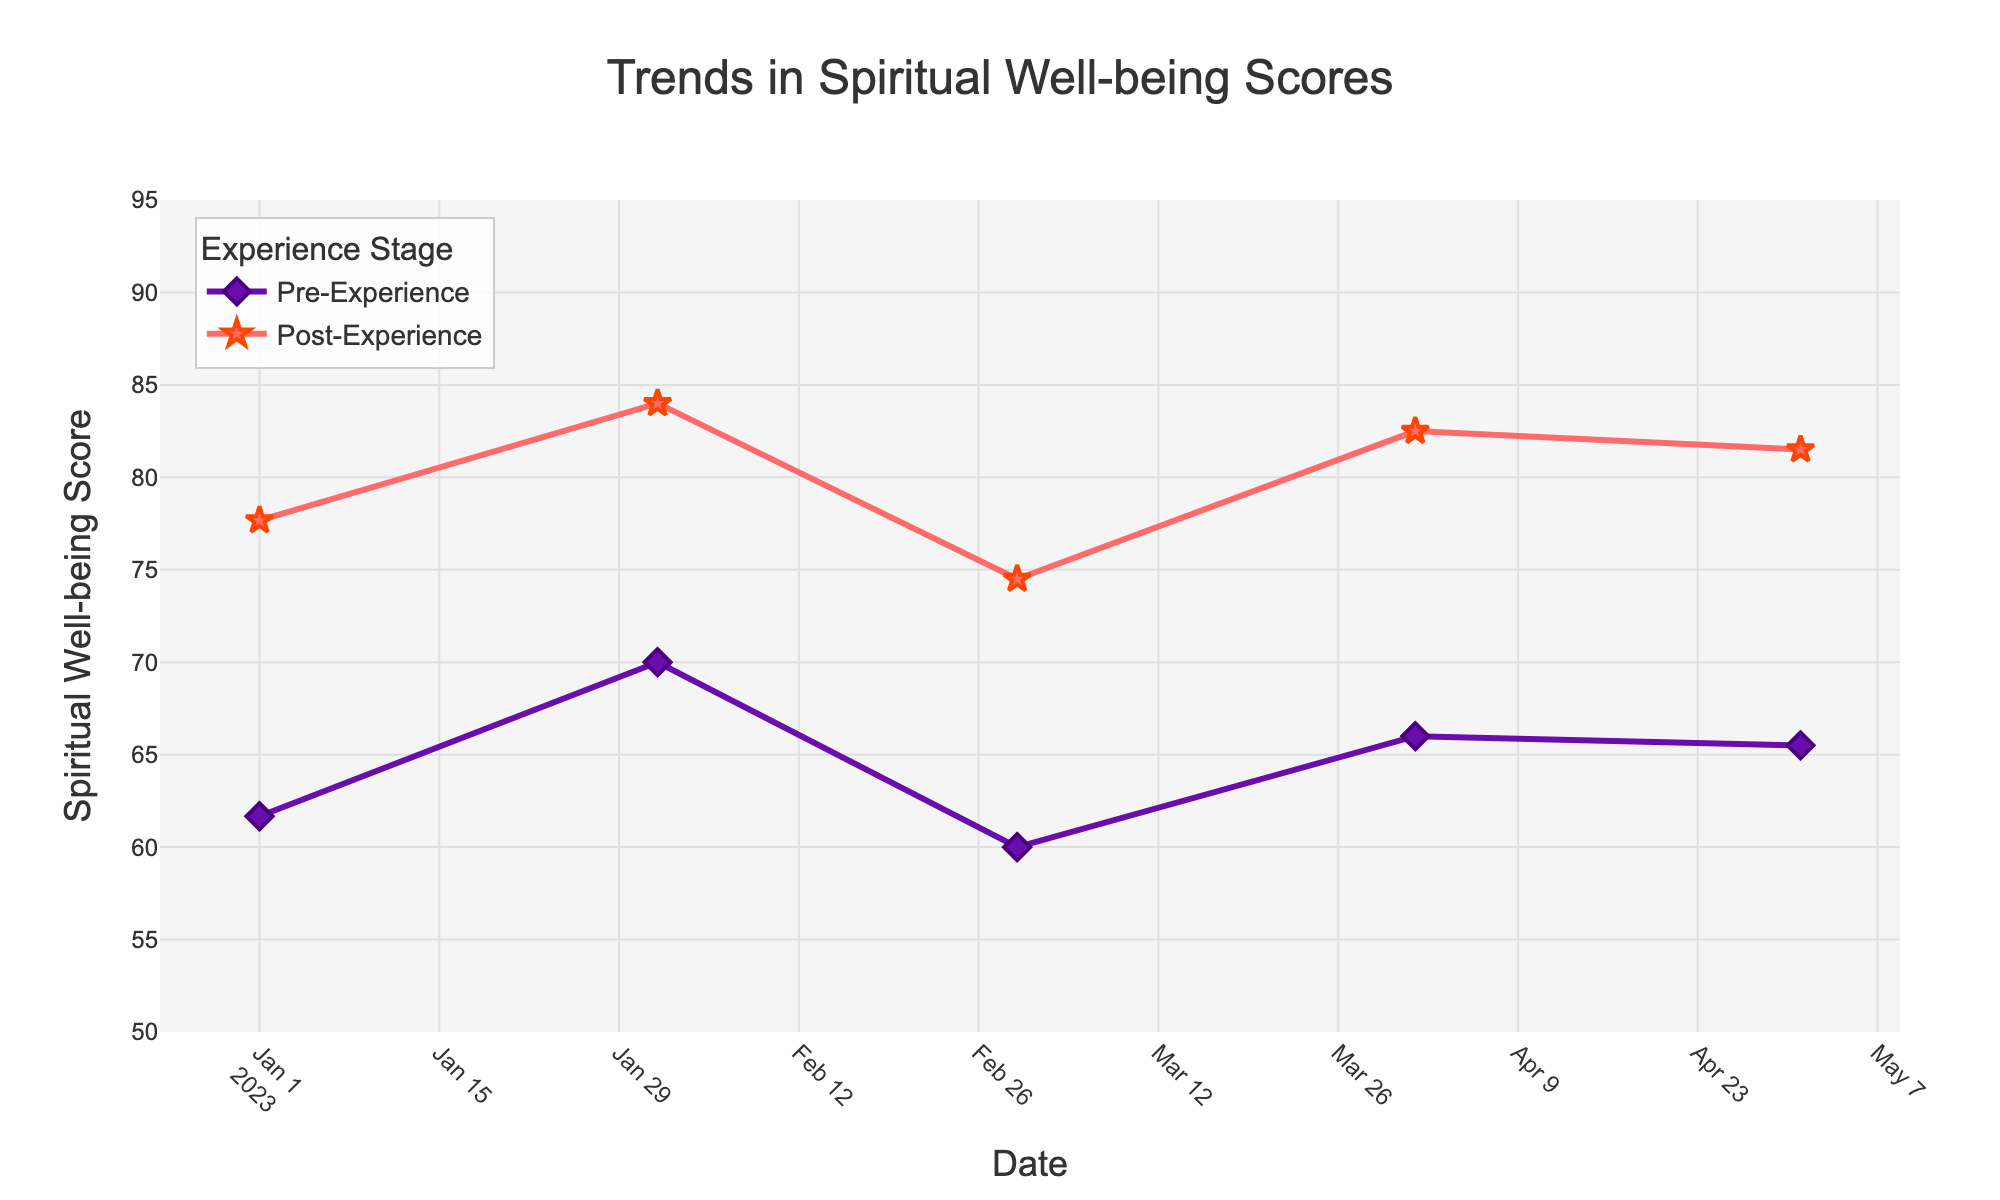What is the title of the figure? The title of the figure is located at the top and gives an overview of what the visual represents. It reads ‘Trends in Spiritual Well-being Scores’.
Answer: Trends in Spiritual Well-being Scores Which experience stage has a higher score on average in January 2023? By looking at the lines and markers for January 2023, the Post-Experience Score is higher than the Pre-Experience Score.
Answer: Post-Experience What is the y-axis representing? The y-axis title indicates it is representing the 'Spiritual Well-being Score'.
Answer: Spiritual Well-being Score Between which two months did the Pre-Experience Score show the most significant increase? To find this, compare the Pre-Experience Score line across the months. The most significant increase is observed between March 2023 and April 2023.
Answer: March 2023 and April 2023 How many data points are plotted for each experience stage? By counting the markers on each line, you can see that there are 5 data points plotted for each experience stage.
Answer: 5 What is the average Post-Experience Score in May 2023? The Post-Experience Score marker for May 2023 is located at 89. Since there is no averaging needed as there is only one data point, the average is 89.
Answer: 89 How does the color and marker shape differ between Pre-Experience and Post-Experience Scores? The Pre-Experience Scores are represented by purple lines with diamond markers, while the Post-Experience Scores are shown with red lines and star markers.
Answer: Purple diamonds and red stars What is the mean difference between Pre-Experience and Post-Experience Scores in February 2023? For February 2023, the Pre-Experience Score is 65, and the Post-Experience Score is 80. The mean difference is calculated by subtracting Pre-Experience from Post-Experience (80 - 65).
Answer: 15 Which month shows the highest Post-Experience Score? By observing the Post-Experience Score line, May 2023 has the highest score at 89.
Answer: May 2023 